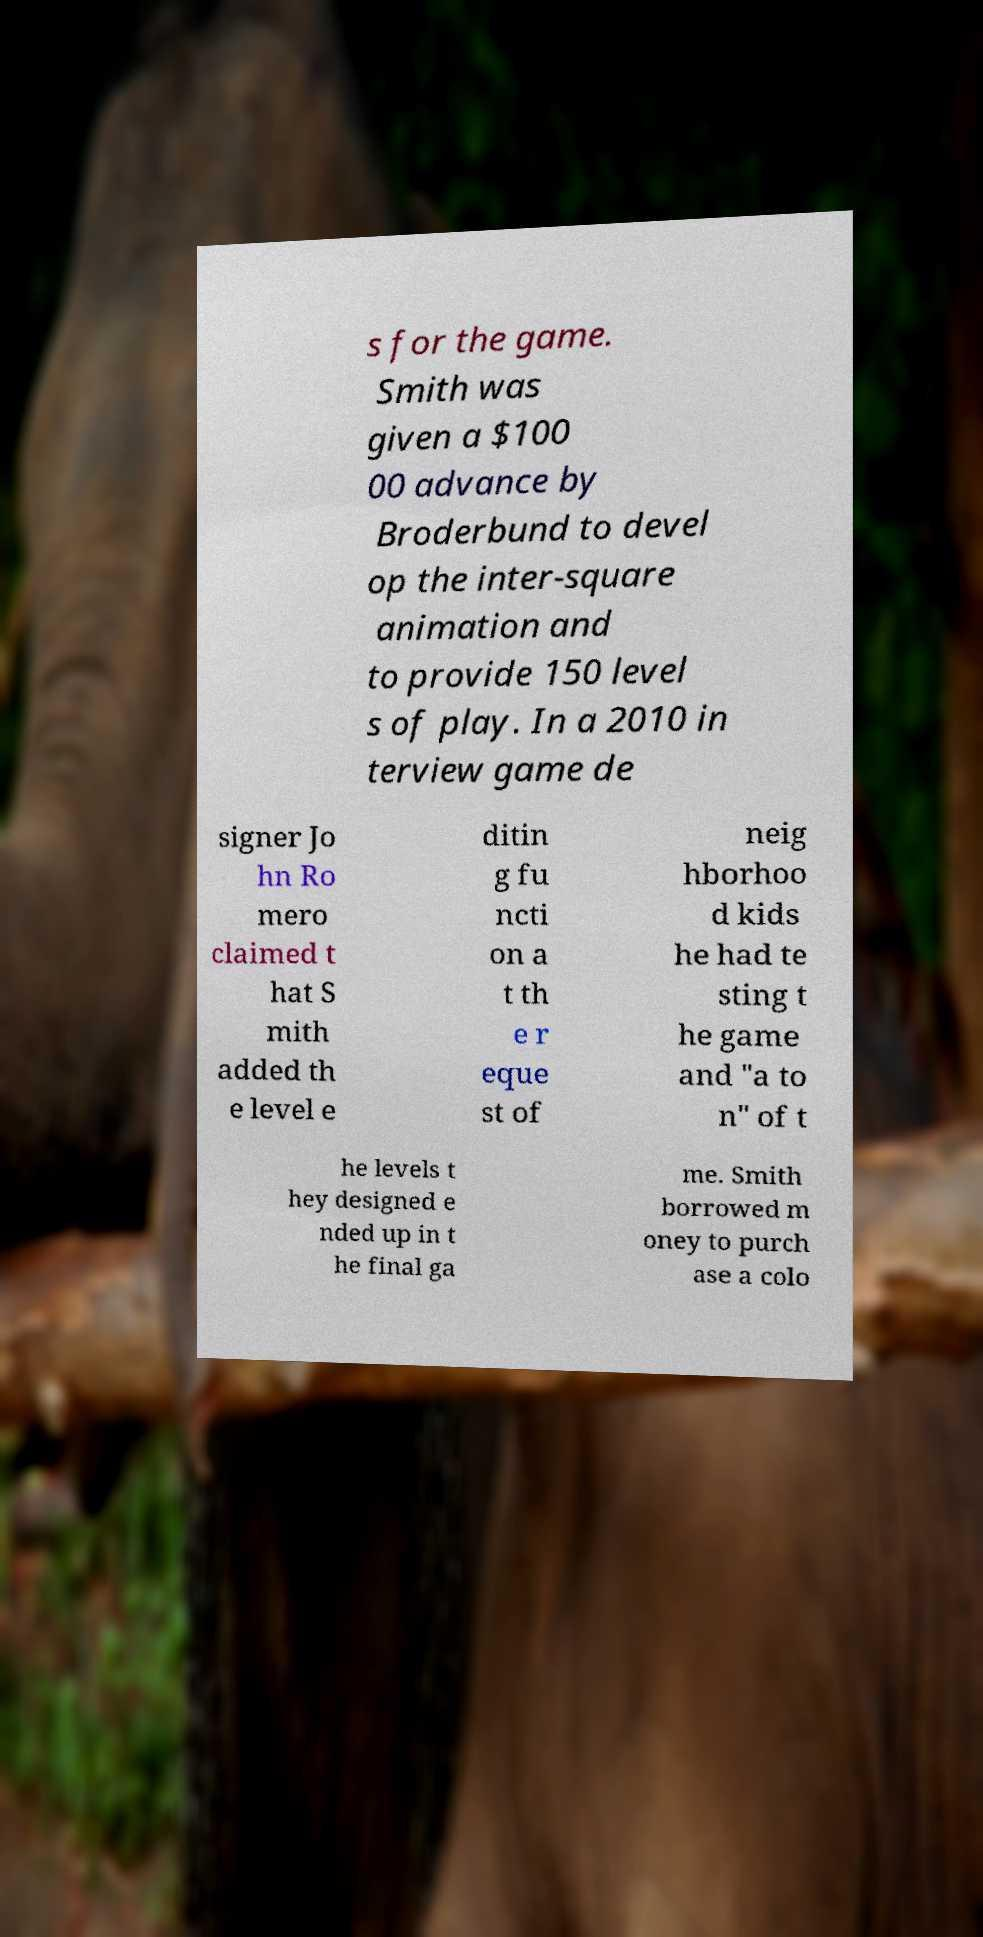Could you assist in decoding the text presented in this image and type it out clearly? s for the game. Smith was given a $100 00 advance by Broderbund to devel op the inter-square animation and to provide 150 level s of play. In a 2010 in terview game de signer Jo hn Ro mero claimed t hat S mith added th e level e ditin g fu ncti on a t th e r eque st of neig hborhoo d kids he had te sting t he game and "a to n" of t he levels t hey designed e nded up in t he final ga me. Smith borrowed m oney to purch ase a colo 